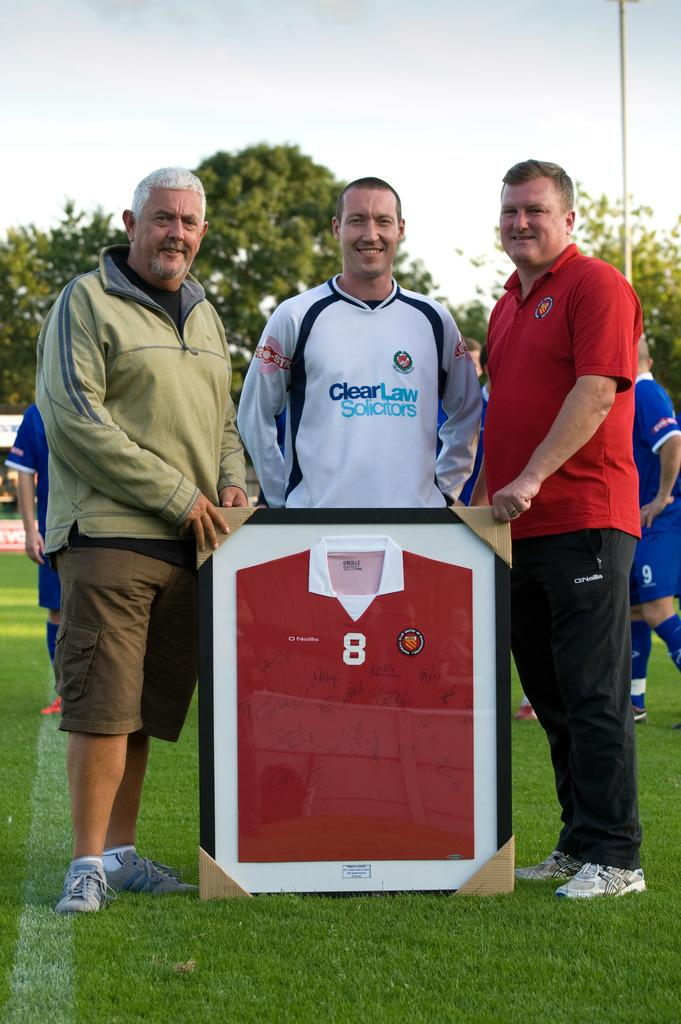<image>
Render a clear and concise summary of the photo. Three men stand besides a framed jersey with number 8 on the front. 